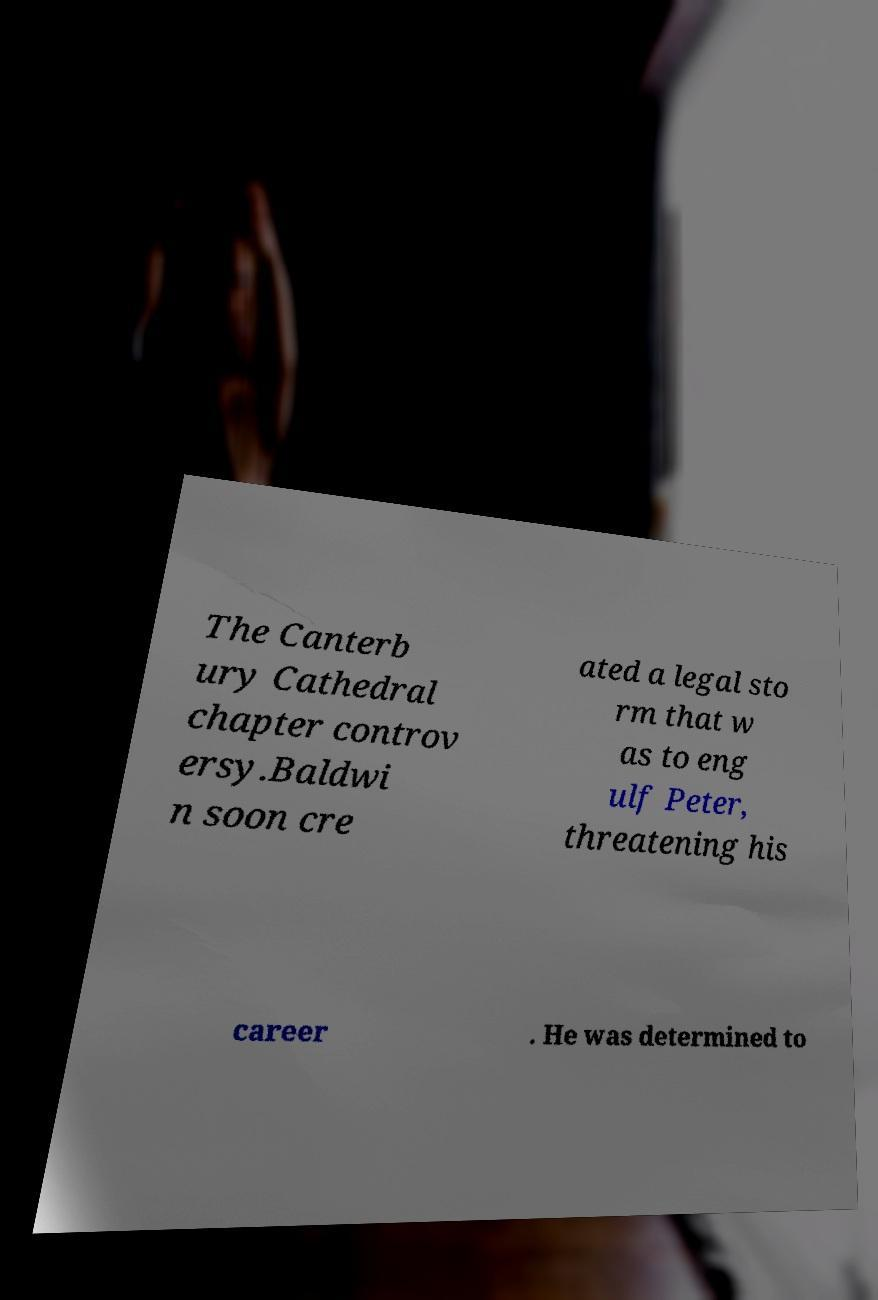Could you assist in decoding the text presented in this image and type it out clearly? The Canterb ury Cathedral chapter controv ersy.Baldwi n soon cre ated a legal sto rm that w as to eng ulf Peter, threatening his career . He was determined to 